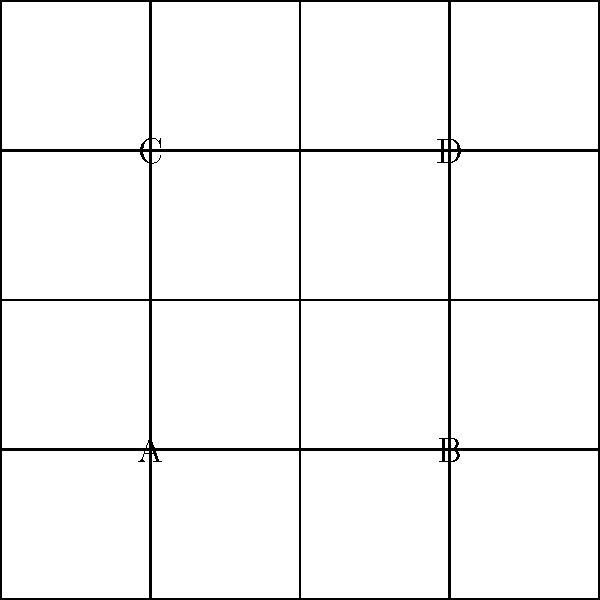In the geometric pattern shown above, inspired by ancient textile designs, identify the group of symmetries that preserve the overall pattern. Which of the following best describes the symmetry group of this interlocking square pattern?

a) $C_4$
b) $D_4$
c) $C_2 \times C_2$
d) $p4m$ To determine the symmetry group of this interlocking square pattern, we need to analyze its symmetries step-by-step:

1. Rotational symmetry:
   - The pattern has 4-fold rotational symmetry (90° rotations) around the center of any square.
   - It also has 2-fold rotational symmetry (180° rotations) around the midpoints of the edges of the squares.

2. Reflection symmetry:
   - There are vertical and horizontal reflection lines through the centers of the squares.
   - There are also diagonal reflection lines through the corners of the squares.

3. Translation symmetry:
   - The pattern can be translated horizontally and vertically to create an infinite tessellation.

4. Glide reflection:
   - The pattern exhibits glide reflections along the lines between rows and columns of squares.

Given these symmetries, we can eliminate some options:
- $C_4$ (cyclic group of order 4) is insufficient as it only accounts for rotations.
- $C_2 \times C_2$ (Klein four-group) is also insufficient as it doesn't capture all the symmetries present.
- $D_4$ (dihedral group of order 8) accounts for rotations and reflections but not translations.

The correct answer is d) $p4m$, which is a wallpaper group that includes all the symmetries we observed:
- 4-fold rotations
- Reflections in four directions
- Translations
- Glide reflections

This group is the most comprehensive description of the symmetries present in the interlocking square pattern, capturing both the local symmetries of individual motifs and the overall symmetry of the repeating pattern.
Answer: $p4m$ 